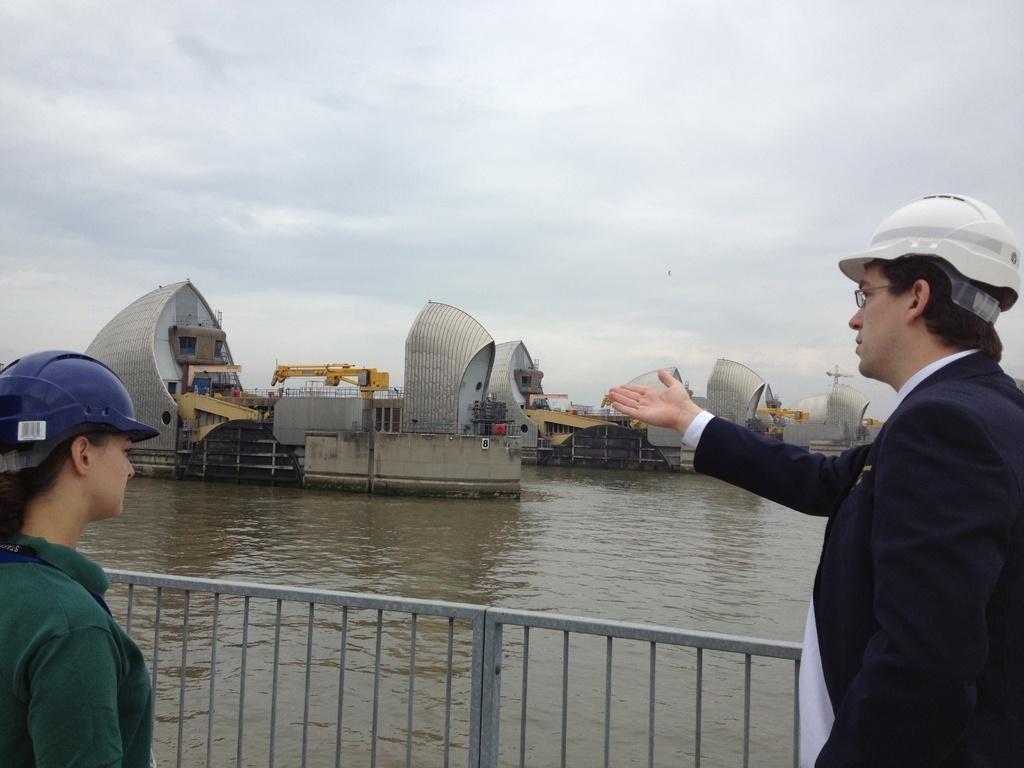Describe this image in one or two sentences. In this image we can see a man and a woman wearing helmets standing beside a fence. We can also see a water body, a group of buildings, crane, pole and the sky which looks cloudy. 